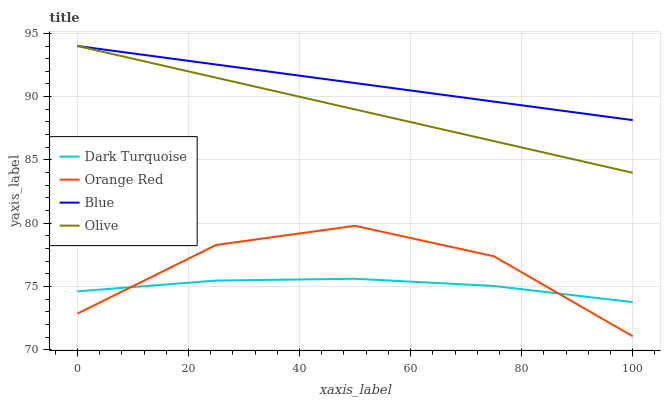Does Dark Turquoise have the minimum area under the curve?
Answer yes or no. Yes. Does Blue have the maximum area under the curve?
Answer yes or no. Yes. Does Orange Red have the minimum area under the curve?
Answer yes or no. No. Does Orange Red have the maximum area under the curve?
Answer yes or no. No. Is Olive the smoothest?
Answer yes or no. Yes. Is Orange Red the roughest?
Answer yes or no. Yes. Is Dark Turquoise the smoothest?
Answer yes or no. No. Is Dark Turquoise the roughest?
Answer yes or no. No. Does Orange Red have the lowest value?
Answer yes or no. Yes. Does Dark Turquoise have the lowest value?
Answer yes or no. No. Does Olive have the highest value?
Answer yes or no. Yes. Does Orange Red have the highest value?
Answer yes or no. No. Is Dark Turquoise less than Blue?
Answer yes or no. Yes. Is Olive greater than Orange Red?
Answer yes or no. Yes. Does Olive intersect Blue?
Answer yes or no. Yes. Is Olive less than Blue?
Answer yes or no. No. Is Olive greater than Blue?
Answer yes or no. No. Does Dark Turquoise intersect Blue?
Answer yes or no. No. 